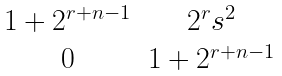<formula> <loc_0><loc_0><loc_500><loc_500>\begin{matrix} 1 + 2 ^ { r + n - 1 } & 2 ^ { r } s ^ { 2 } \\ 0 & 1 + 2 ^ { r + n - 1 } \end{matrix}</formula> 